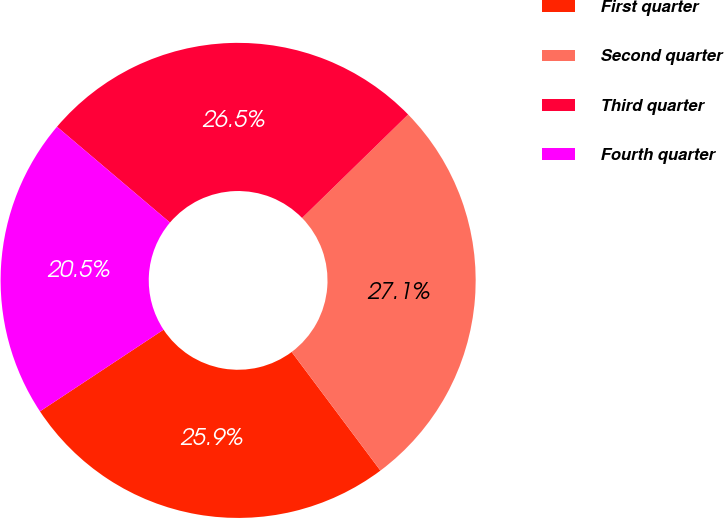<chart> <loc_0><loc_0><loc_500><loc_500><pie_chart><fcel>First quarter<fcel>Second quarter<fcel>Third quarter<fcel>Fourth quarter<nl><fcel>25.93%<fcel>27.08%<fcel>26.5%<fcel>20.49%<nl></chart> 